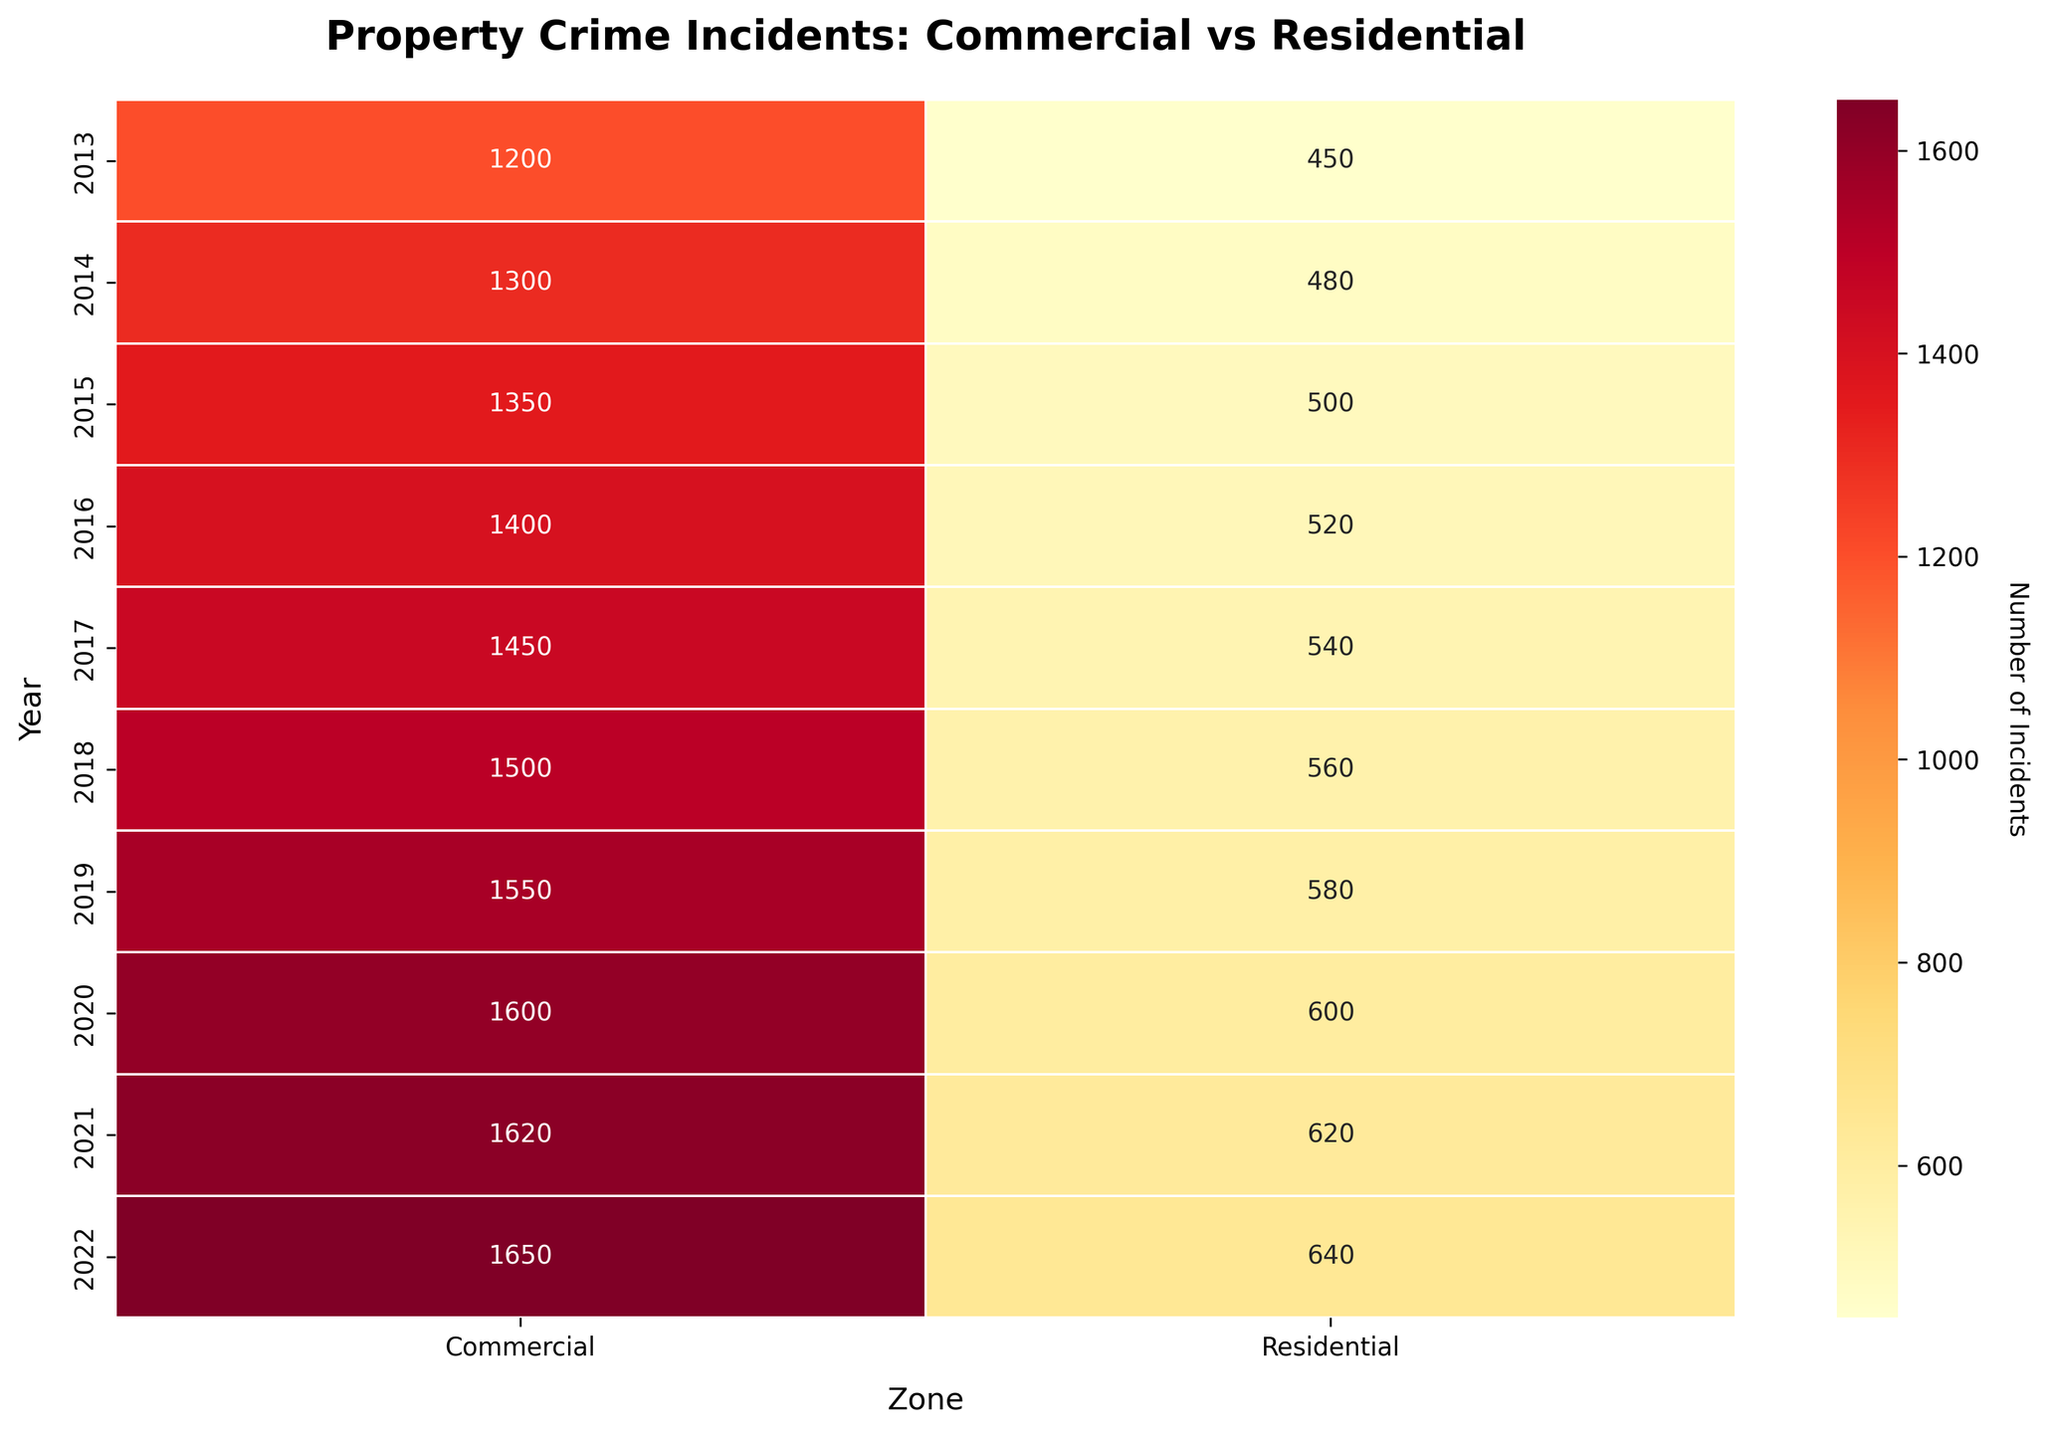What is the title of the heatmap? Look at the top of the heatmap where the title is usually located to identify what the plot represents. The title of the figure is "Property Crime Incidents: Commercial vs Residential."
Answer: Property Crime Incidents: Commercial vs Residential How many years of data are displayed in the heatmap? Check the vertical axis which represents the years. The year range starts from 2013 and ends in 2022. Count the years between 2013 and 2022, inclusive.
Answer: 10 Which year had the highest number of property crime incidents in the commercial zone? On the vertical axis, iterate through each year and observe the values for the commercial zone. The highest value is found in 2022.
Answer: 2022 In which year(s) did residential zones have less than 500 property crime incidents? Examine the vertical axis for residential zone values. The values for years 2013, 2014, and 2015 are below 500.
Answer: 2013, 2014, 2015 What is the difference in property crime incidents between commercial and residential zones in 2020? Identify and subtract the values for both zones in the year 2020. The commercial zone had 1600 incidents and the residential zone had 600 incidents, yielding a difference of 1600 - 600.
Answer: 1000 What is the overall trend of property crime incidents in residential zones over the decade? Examine the heatmap's gradient and annotations for the residential zone over the years. The general pattern shows a gradual increase from 450 in 2013 to 640 in 2022.
Answer: Increasing Compare the property crime incidents between commercial and residential zones in 2015. Which zone had more incidents? Look at the numbers for both zones in the year 2015. The commercial zone had 1350 incidents, while the residential zone had 500 incidents.
Answer: Commercial What is the average number of property crime incidents in residential zones from 2013 to 2022? Sum the values for residential zones from 2013 to 2022 and divide by the number of years. Total is 450+480+500+520+540+560+580+600+620+640 = 5490, divide it by the number of years, which is 10.
Answer: 549 Explain the color gradient used in the heatmap Look at the color scale and how it changes from lighter to darker shades. The gradient moves from lighter (representing lower numbers) to darker shades (representing higher numbers), specifically using a 'YlOrRd' colormap.
Answer: Lighter to darker Which year had the smallest difference in property crime incidents between commercial and residential zones? Calculate the differences for each year and identify the smallest one. For example, for 2013, the difference is 750, for 2014 it's 820, and so on. You will find that 2021 had the smallest difference (1620 - 620 = 1000).
Answer: 2021 